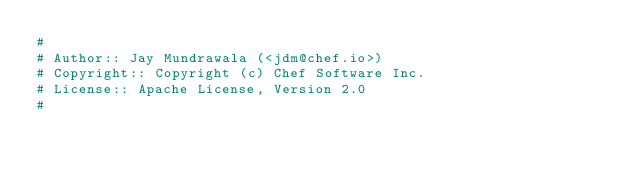<code> <loc_0><loc_0><loc_500><loc_500><_Ruby_>#
# Author:: Jay Mundrawala (<jdm@chef.io>)
# Copyright:: Copyright (c) Chef Software Inc.
# License:: Apache License, Version 2.0
#</code> 